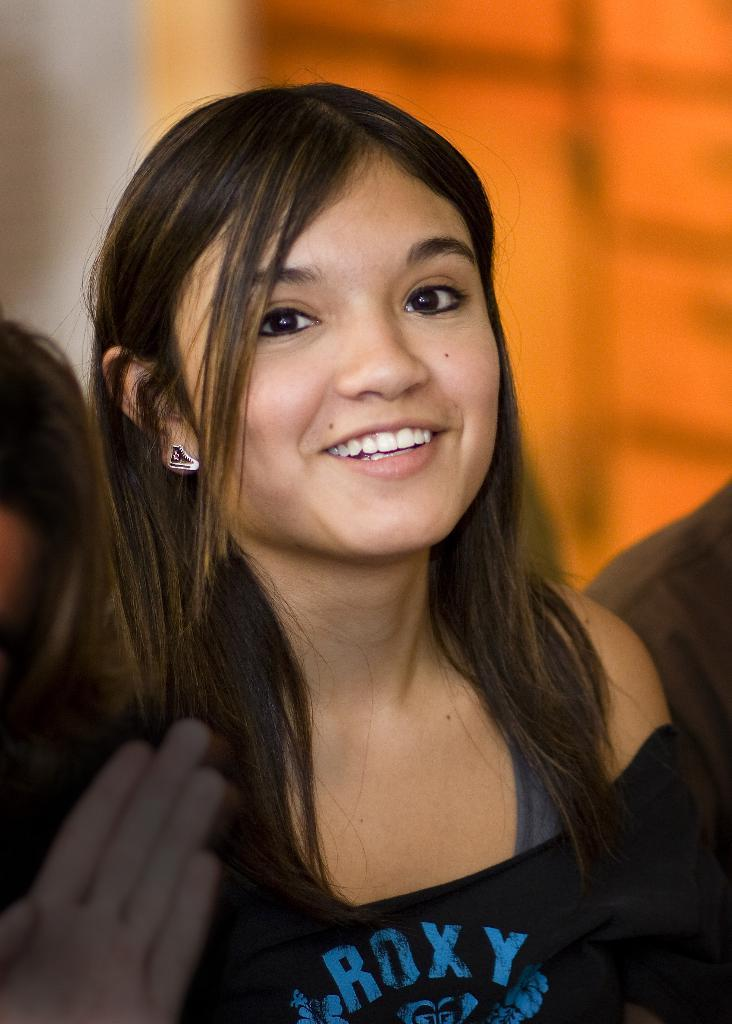Who is the main subject in the image? There is a person in the center of the image. What is the facial expression of the person? The person has a smile on her face. Are there any other people in the image? Yes, there are a few other people beside her. Can you describe the background of the image? The background of the image is blurred. What type of glove is the person wearing in the image? There is no glove visible in the image. What knowledge can be gained from the sail in the image? There is no sail present in the image, so no knowledge can be gained from it. 